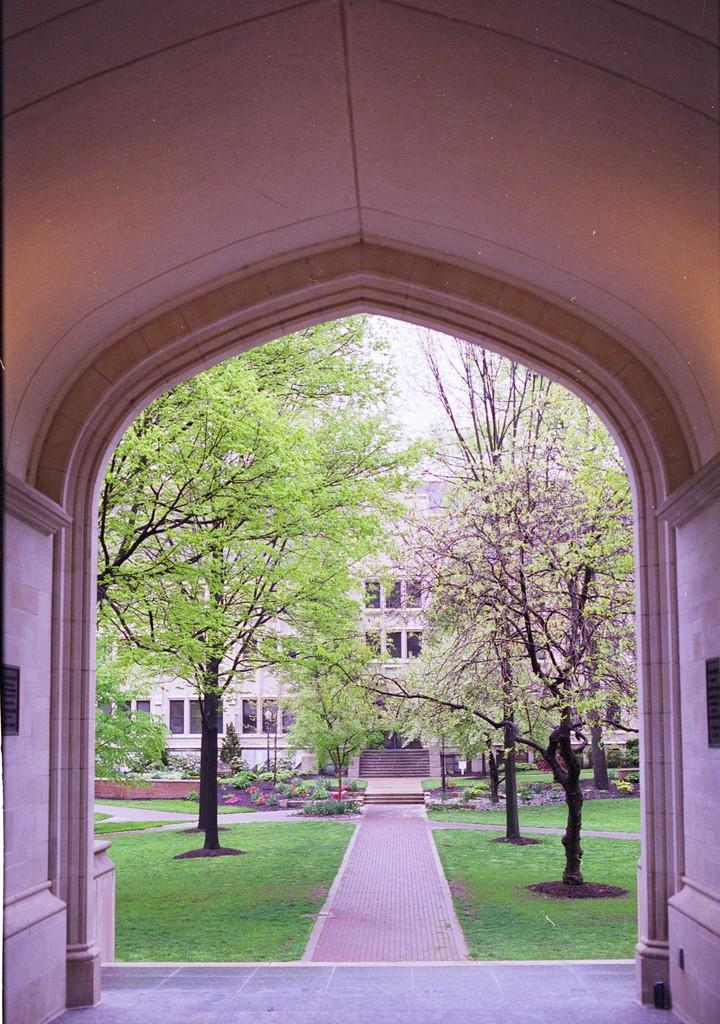What structure is the main focus of the image? There is an arch in the image. What is located behind the arch? There is a path behind the arch. What type of vegetation is present around the path? Grass, trees, and plants are visible around the path. What can be seen in the background of the image? There is a building in the background of the image. What advertisement can be seen on the arch in the image? There is no advertisement present on the arch in the image. Is there any blood visible on the path in the image? There is no blood visible on the path in the image. 